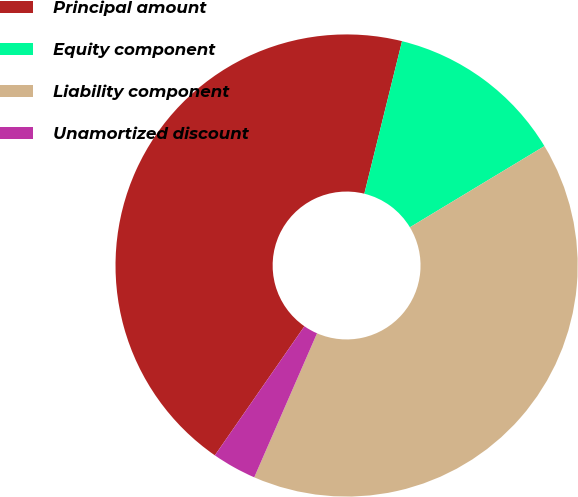Convert chart to OTSL. <chart><loc_0><loc_0><loc_500><loc_500><pie_chart><fcel>Principal amount<fcel>Equity component<fcel>Liability component<fcel>Unamortized discount<nl><fcel>44.2%<fcel>12.5%<fcel>40.18%<fcel>3.11%<nl></chart> 